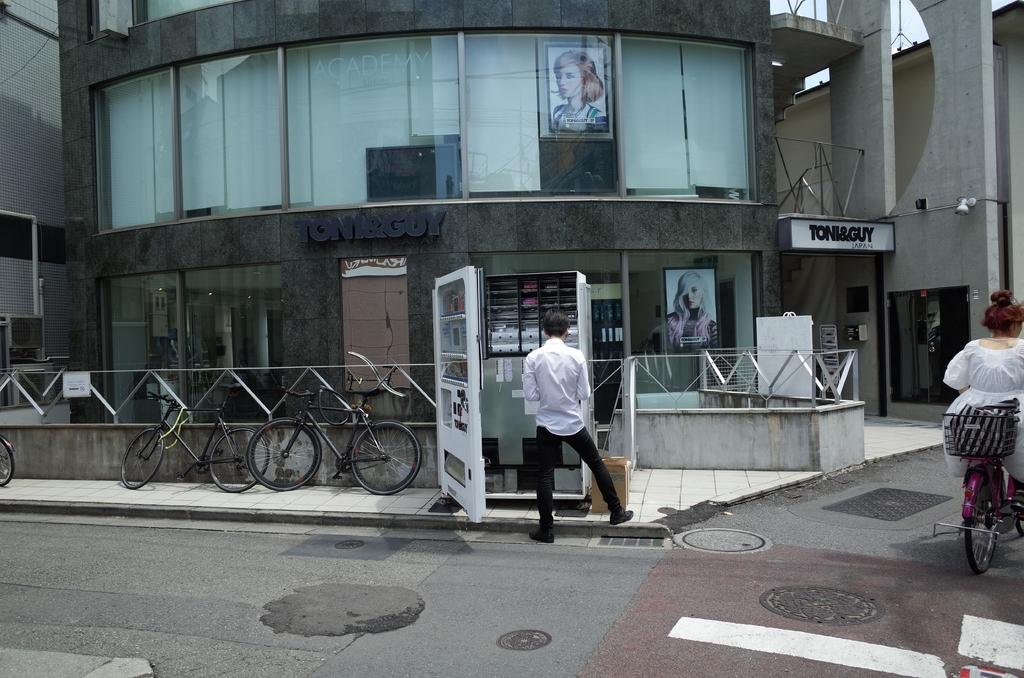What is the main subject of the image in this scene? The image depicts a road. What activity is taking place on the road? There is a woman riding a bicycle on the road. What can be seen near the road? There is a man standing near a booth. Where are more bicycles located in the image? There are bicycles near a store in the image. What type of bait is the minister using to catch fish in the image? There is no minister or fishing activity present in the image. What type of building is visible in the image? The provided facts do not mention any buildings in the image. 